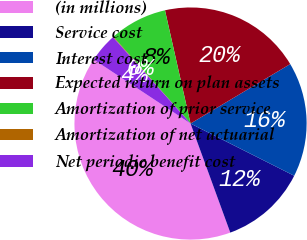Convert chart. <chart><loc_0><loc_0><loc_500><loc_500><pie_chart><fcel>(in millions)<fcel>Service cost<fcel>Interest cost<fcel>Expected return on plan assets<fcel>Amortization of prior service<fcel>Amortization of net actuarial<fcel>Net periodic benefit cost<nl><fcel>39.86%<fcel>12.01%<fcel>15.99%<fcel>19.97%<fcel>8.03%<fcel>0.08%<fcel>4.06%<nl></chart> 